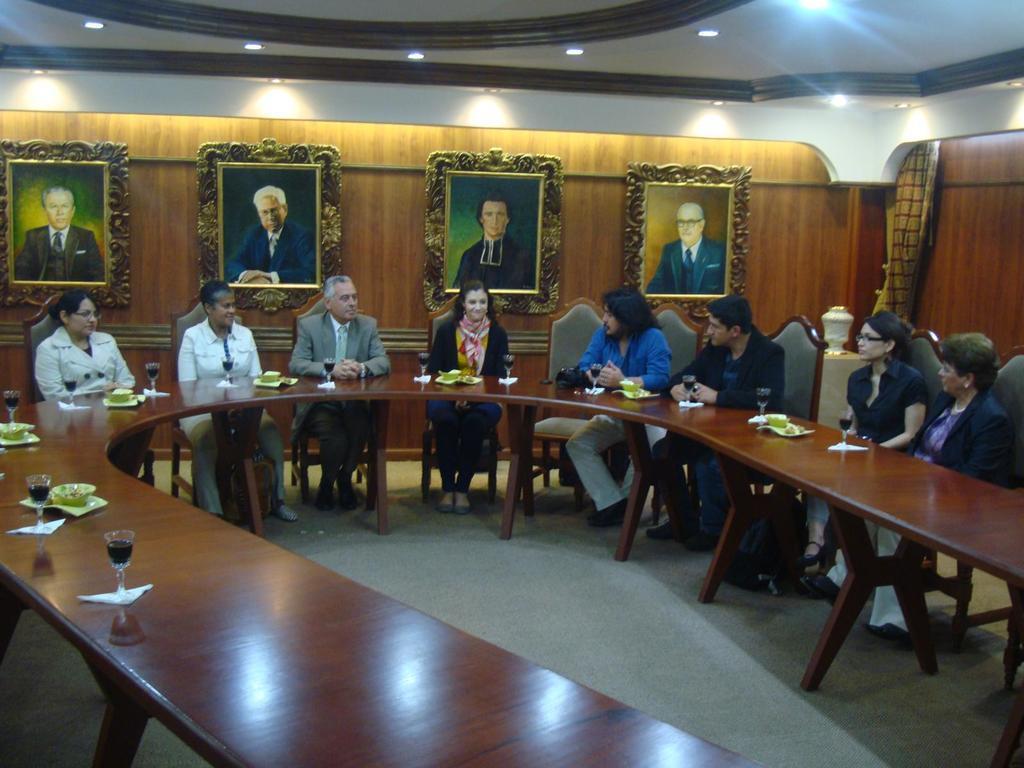Could you give a brief overview of what you see in this image? Some men and women are sitting on the chair in a round table. There are some glasses and plates on this table. In the background there is a wall and on the wall some photo frames are kept. 